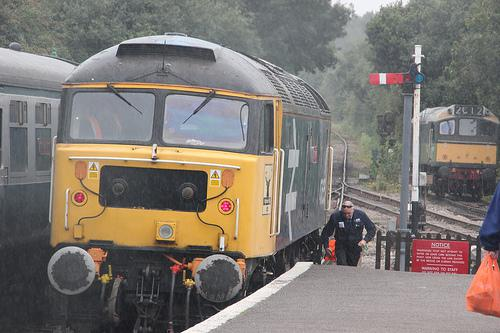Question: what is the man wearing on his head?
Choices:
A. Sunglasses.
B. A hat.
C. A bandanna.
D. A headband.
Answer with the letter. Answer: A Question: how many windshield wipers are depicted?
Choices:
A. Six.
B. Four.
C. Eight.
D. Two.
Answer with the letter. Answer: D Question: what is the color of the roof of the train?
Choices:
A. Red.
B. Blue.
C. Black.
D. Yellow.
Answer with the letter. Answer: C Question: where was the picture taken?
Choices:
A. At a concert.
B. In an arena.
C. In the town square.
D. A train station.
Answer with the letter. Answer: D 